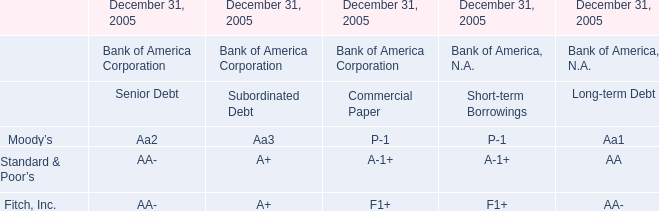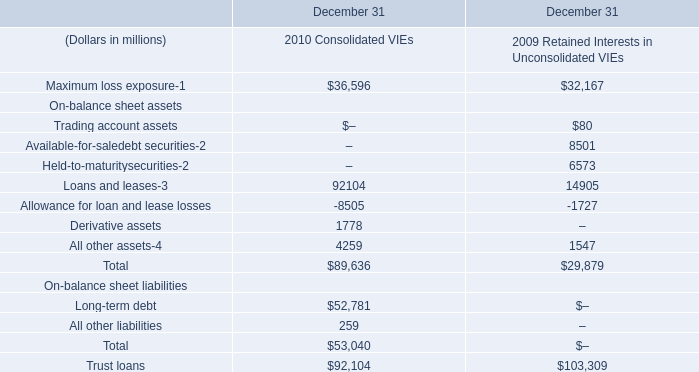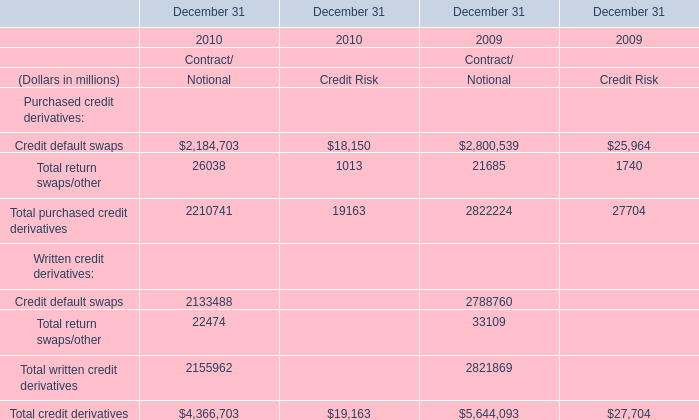What's the current growth rate of Credit default swaps of Purchased credit derivatives of Contract/Notional? 
Computations: ((2184703 - 2800539) / 2800539)
Answer: -0.2199. 